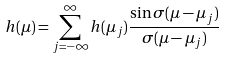Convert formula to latex. <formula><loc_0><loc_0><loc_500><loc_500>h ( \mu ) = \sum _ { j = - \infty } ^ { \infty } h ( \mu _ { j } ) \frac { \sin \sigma ( \mu - \mu _ { j } ) } { \sigma ( \mu - \mu _ { j } ) }</formula> 